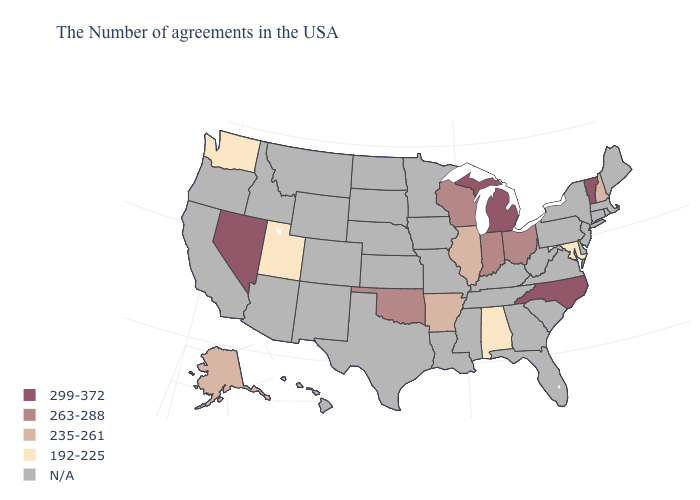Does North Carolina have the highest value in the South?
Write a very short answer. Yes. What is the value of New Hampshire?
Be succinct. 235-261. What is the lowest value in the Northeast?
Answer briefly. 235-261. Name the states that have a value in the range 235-261?
Quick response, please. New Hampshire, Illinois, Arkansas, Alaska. Does Alabama have the lowest value in the USA?
Short answer required. Yes. Does Oklahoma have the highest value in the USA?
Give a very brief answer. No. What is the value of Colorado?
Quick response, please. N/A. What is the value of Maryland?
Concise answer only. 192-225. Does Utah have the lowest value in the West?
Short answer required. Yes. Name the states that have a value in the range 235-261?
Keep it brief. New Hampshire, Illinois, Arkansas, Alaska. 